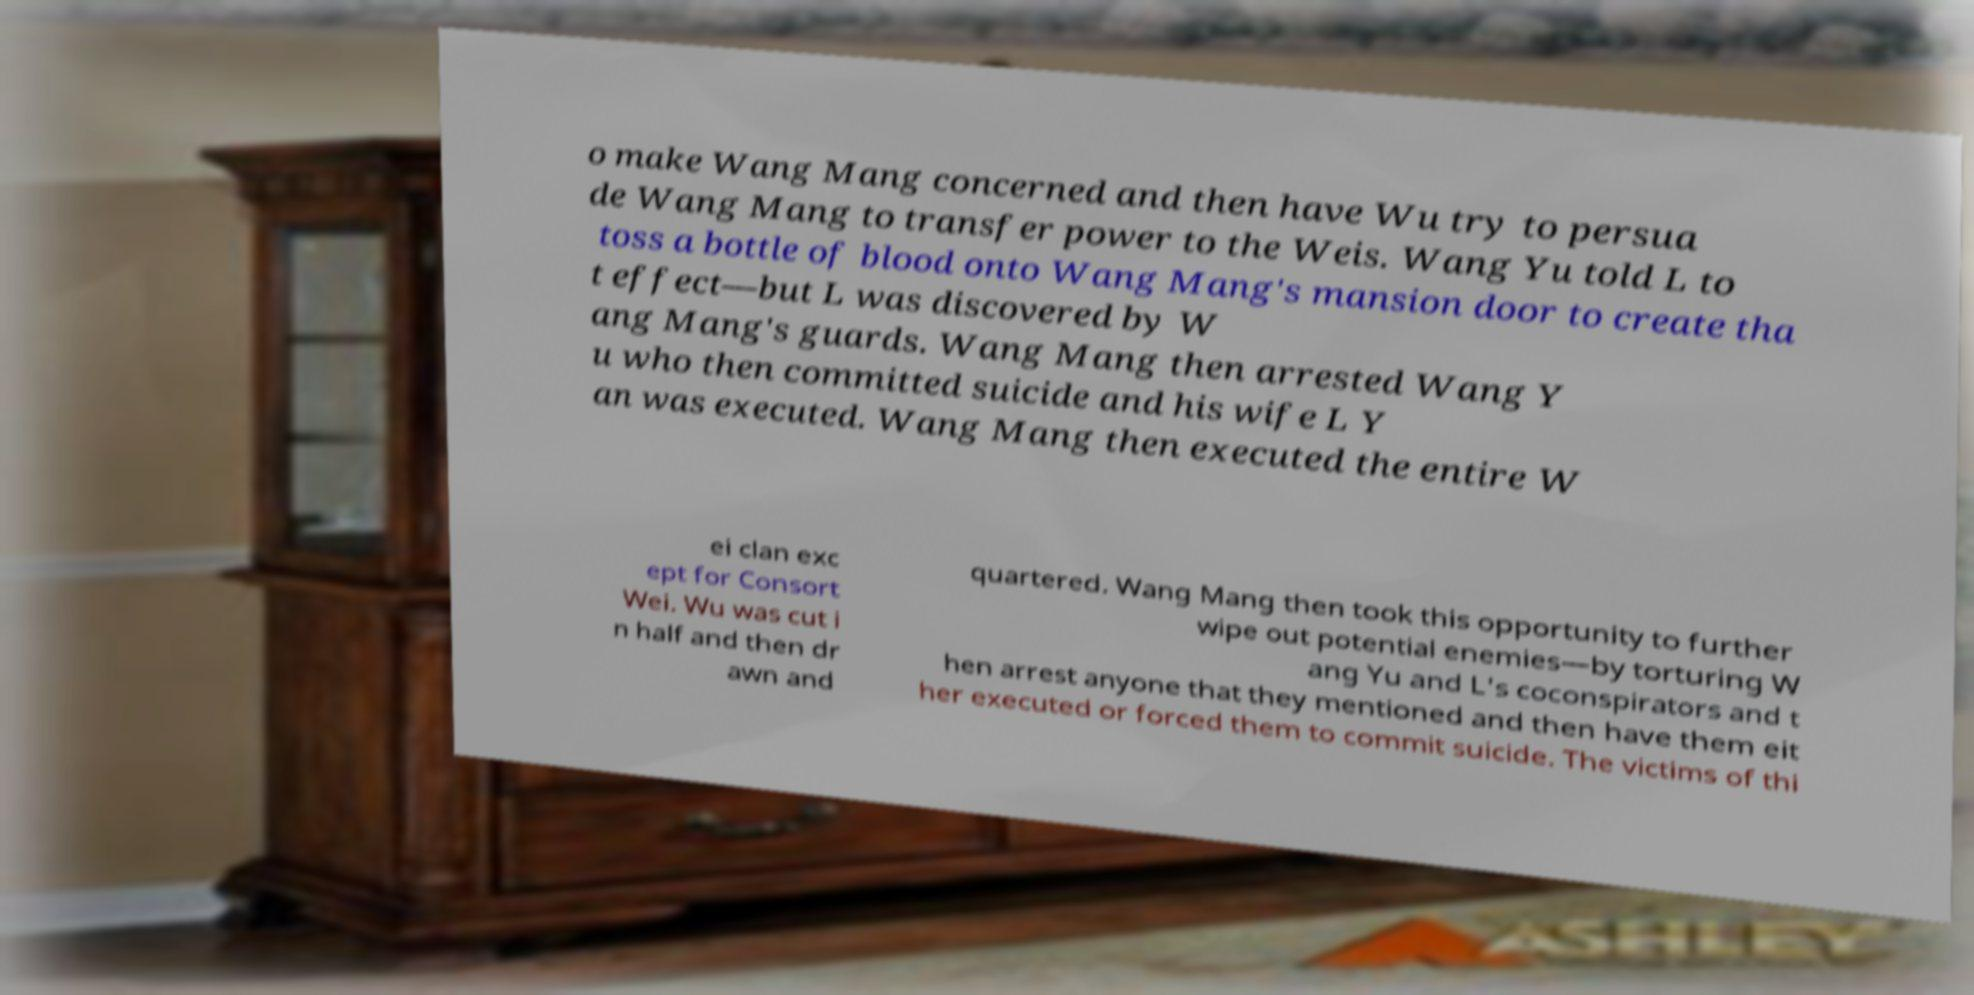Could you assist in decoding the text presented in this image and type it out clearly? o make Wang Mang concerned and then have Wu try to persua de Wang Mang to transfer power to the Weis. Wang Yu told L to toss a bottle of blood onto Wang Mang's mansion door to create tha t effect—but L was discovered by W ang Mang's guards. Wang Mang then arrested Wang Y u who then committed suicide and his wife L Y an was executed. Wang Mang then executed the entire W ei clan exc ept for Consort Wei. Wu was cut i n half and then dr awn and quartered. Wang Mang then took this opportunity to further wipe out potential enemies—by torturing W ang Yu and L's coconspirators and t hen arrest anyone that they mentioned and then have them eit her executed or forced them to commit suicide. The victims of thi 